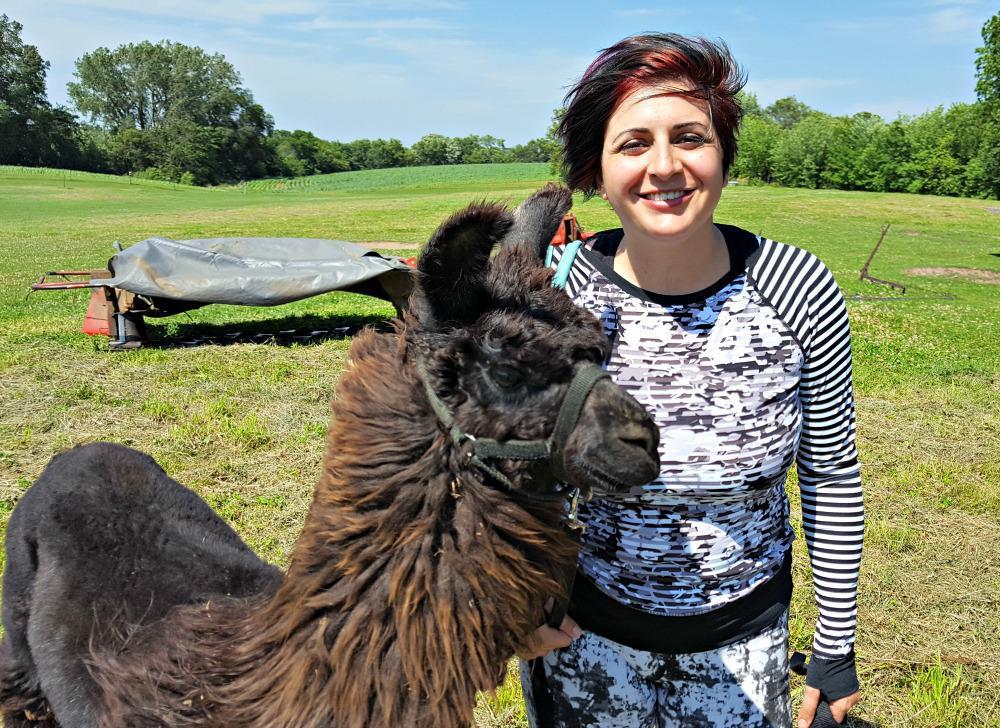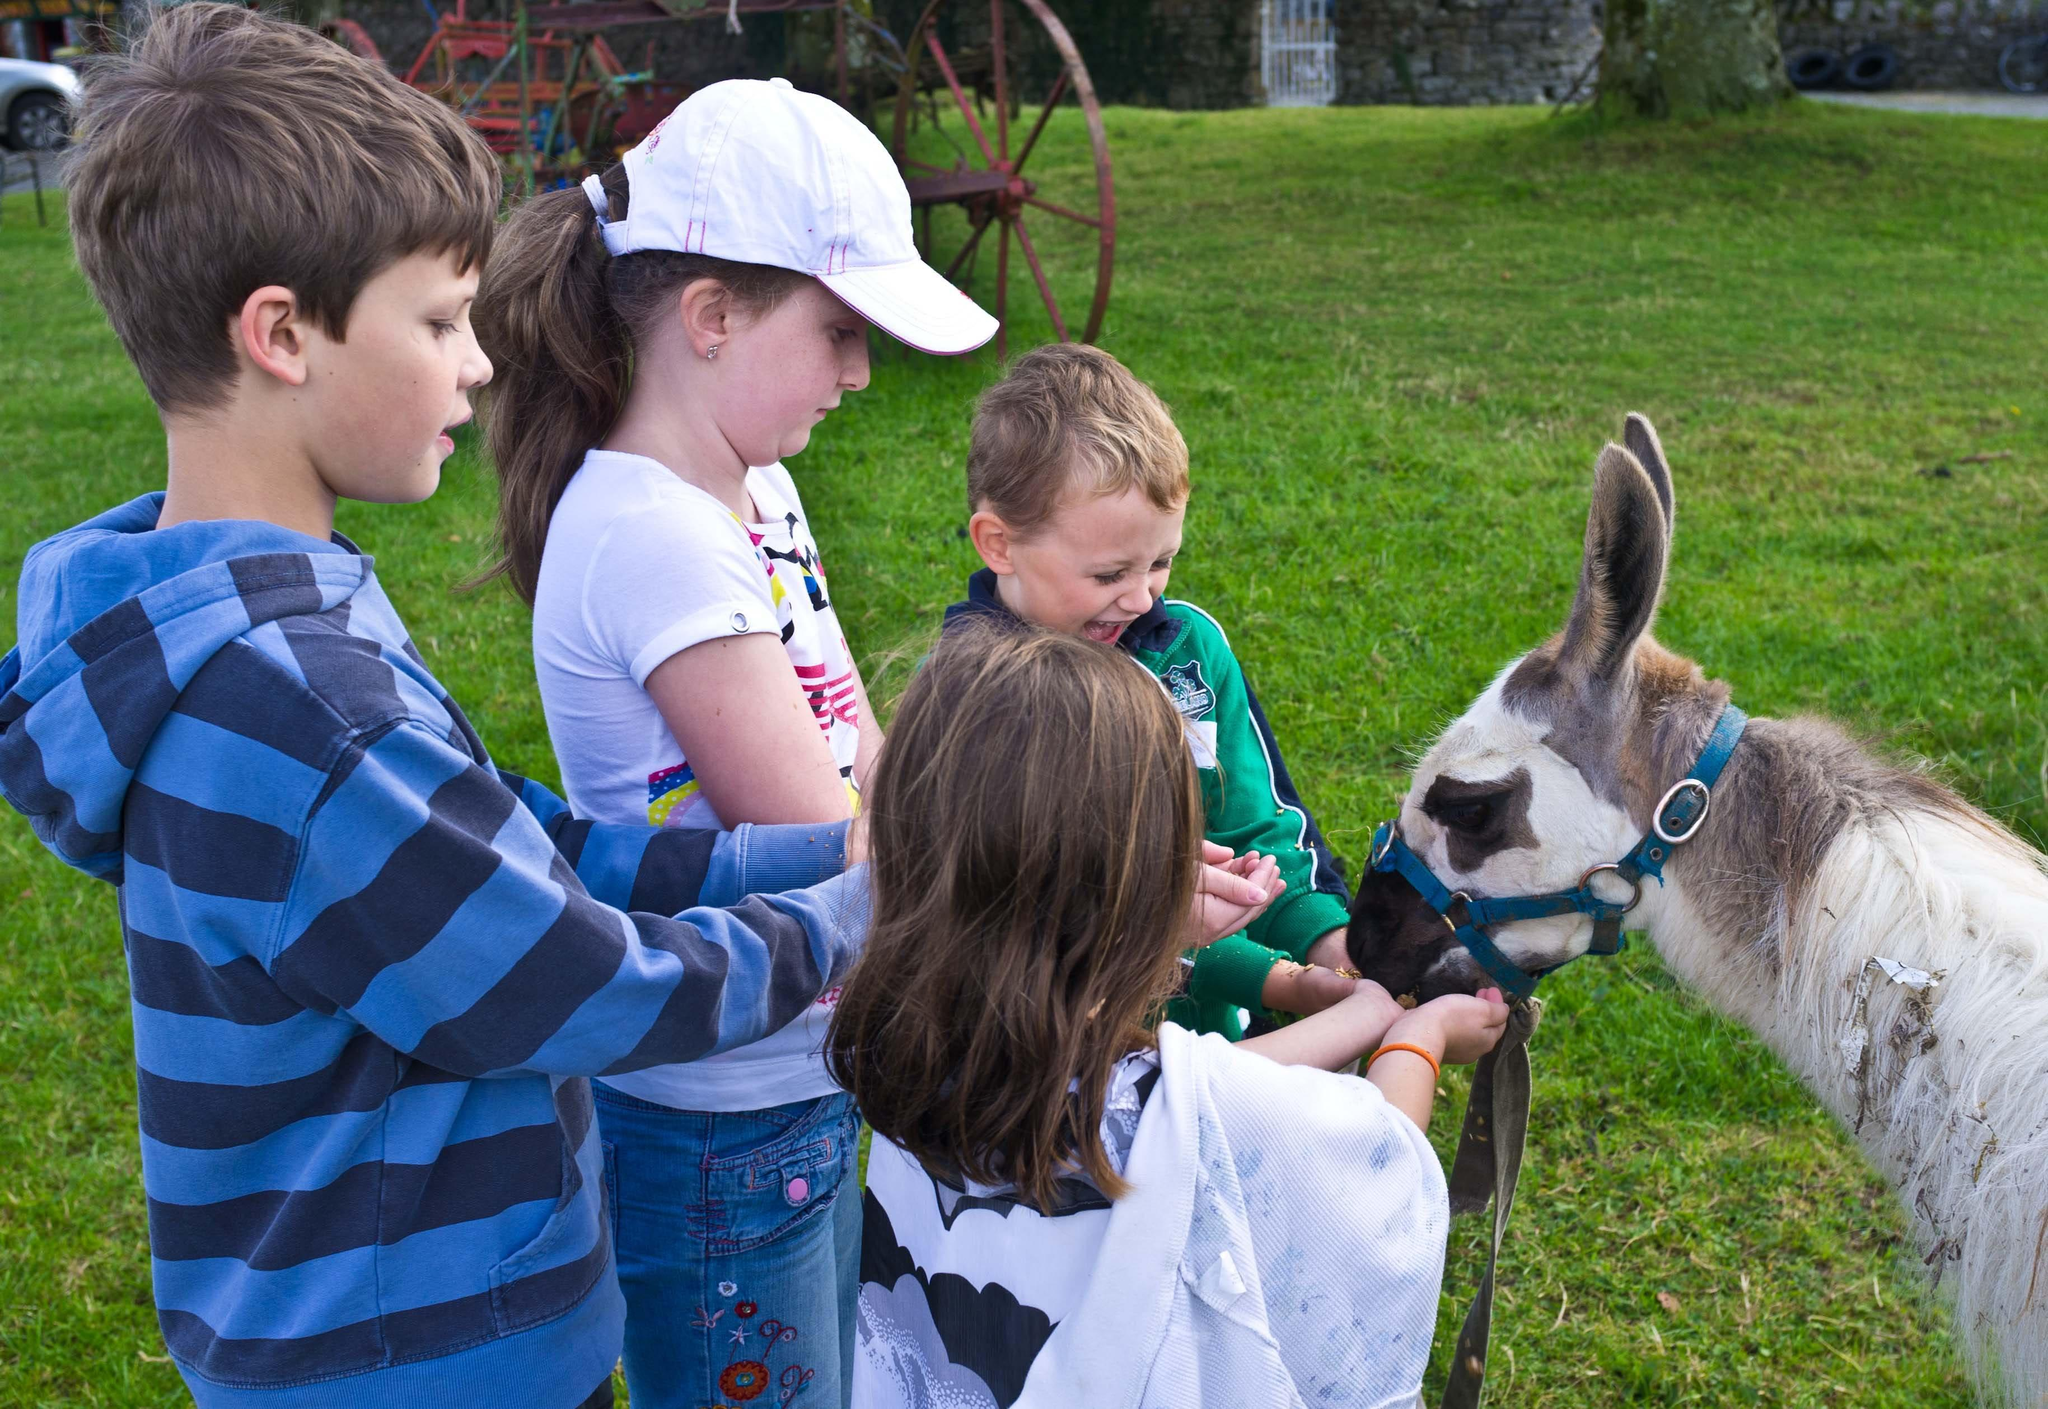The first image is the image on the left, the second image is the image on the right. Considering the images on both sides, is "In one image, multiple children are standing in front of at least one llama, with their hands outstretched to feed it." valid? Answer yes or no. Yes. The first image is the image on the left, the second image is the image on the right. Examine the images to the left and right. Is the description "There are children feeding a llama." accurate? Answer yes or no. Yes. 